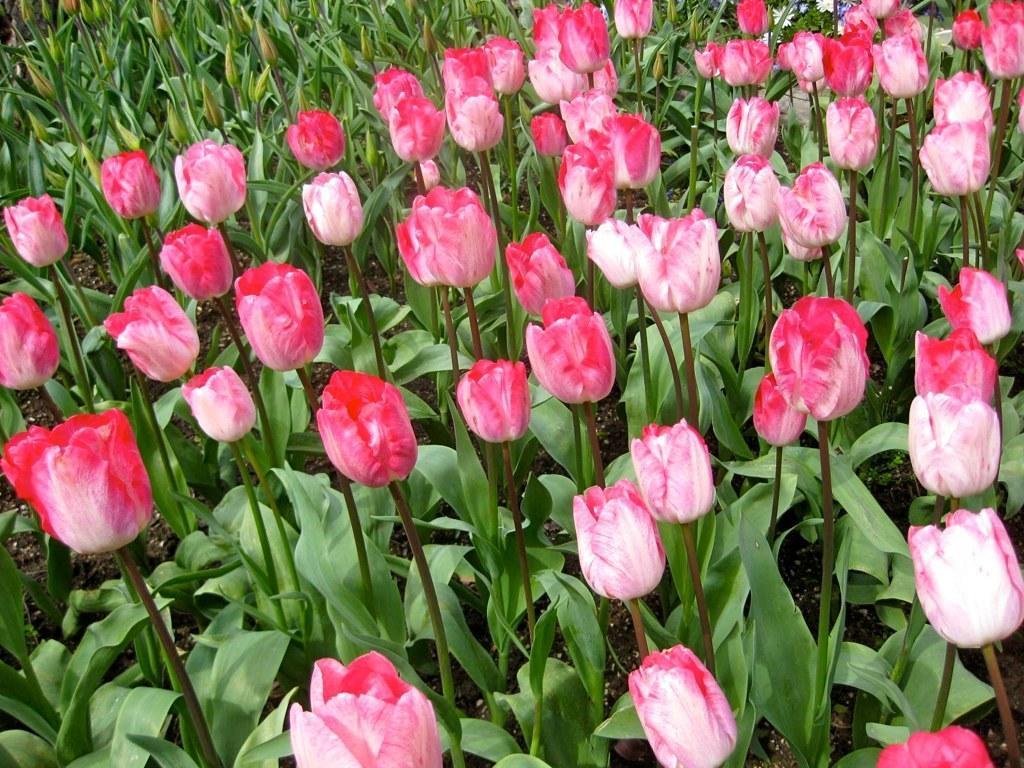In one or two sentences, can you explain what this image depicts? In this picture, there are plants with pink tulip flowers. 